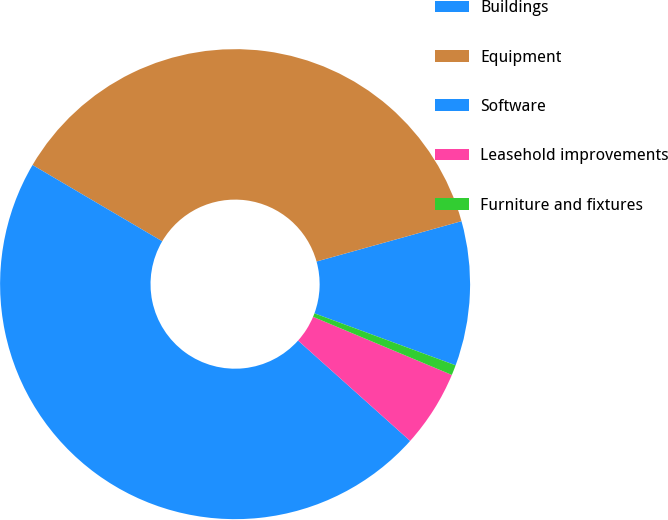Convert chart. <chart><loc_0><loc_0><loc_500><loc_500><pie_chart><fcel>Buildings<fcel>Equipment<fcel>Software<fcel>Leasehold improvements<fcel>Furniture and fixtures<nl><fcel>9.93%<fcel>37.22%<fcel>46.84%<fcel>5.31%<fcel>0.7%<nl></chart> 